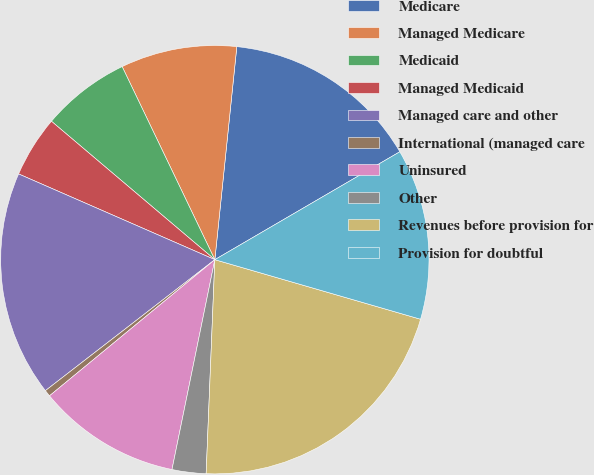Convert chart to OTSL. <chart><loc_0><loc_0><loc_500><loc_500><pie_chart><fcel>Medicare<fcel>Managed Medicare<fcel>Medicaid<fcel>Managed Medicaid<fcel>Managed care and other<fcel>International (managed care<fcel>Uninsured<fcel>Other<fcel>Revenues before provision for<fcel>Provision for doubtful<nl><fcel>14.96%<fcel>8.76%<fcel>6.69%<fcel>4.63%<fcel>17.03%<fcel>0.49%<fcel>10.83%<fcel>2.56%<fcel>21.16%<fcel>12.89%<nl></chart> 